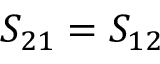<formula> <loc_0><loc_0><loc_500><loc_500>S _ { 2 1 } = S _ { 1 2 }</formula> 